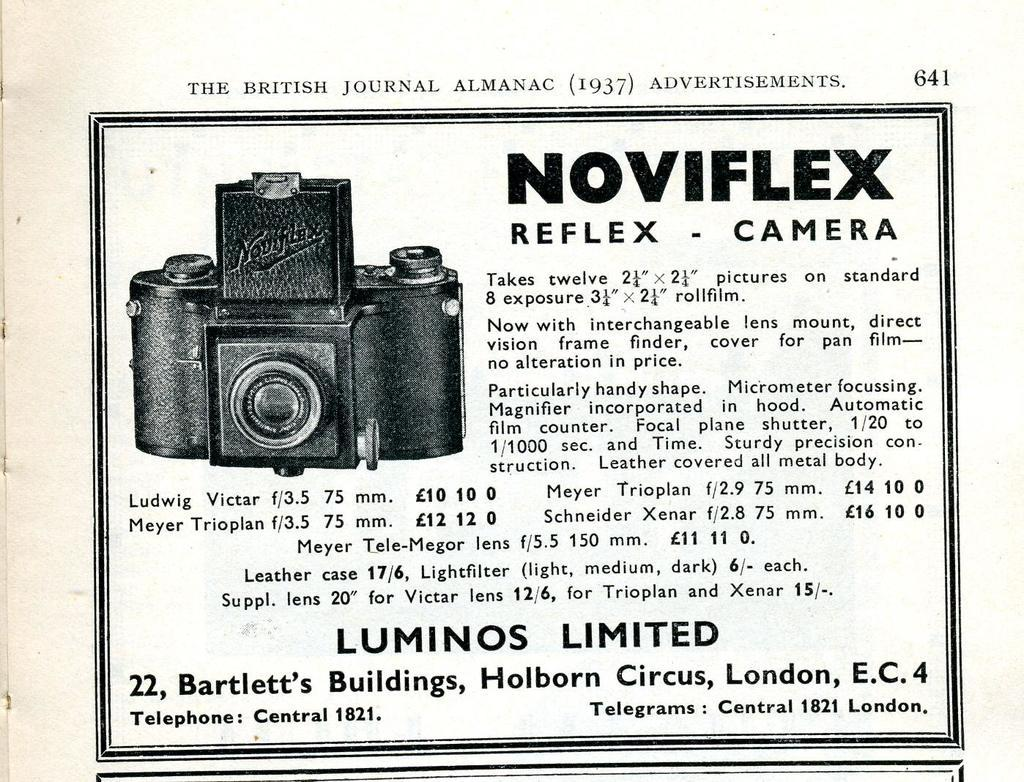What is the main subject of the image? The main subject of the image is a black and white picture of a camera. How is the picture of the camera presented? The picture of the camera is on a paper. What else can be seen in the image besides the picture of the camera? There is text beside the picture of the camera. How many bricks are visible in the image? There are no bricks present in the image. Is there a boy playing with a home in the image? There is no boy or home depicted in the image. 